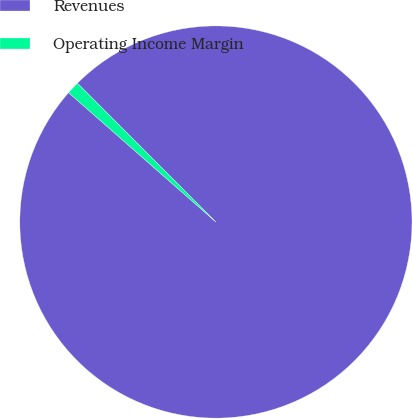<chart> <loc_0><loc_0><loc_500><loc_500><pie_chart><fcel>Revenues<fcel>Operating Income Margin<nl><fcel>98.95%<fcel>1.05%<nl></chart> 